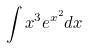<formula> <loc_0><loc_0><loc_500><loc_500>\int x ^ { 3 } e ^ { x ^ { 2 } } d x</formula> 